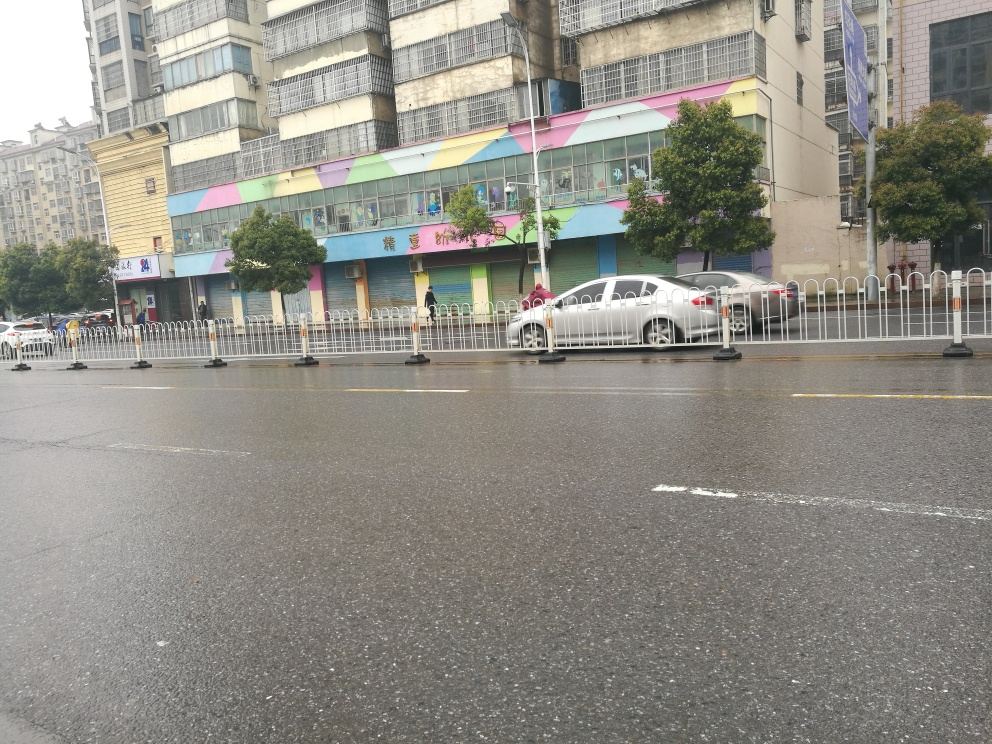Can you tell me more about the setting of this image? This image captures a street scene likely in a commercial or mixed residential area, given the storefronts with colorful facades. The barricades along the road could indicate that there is moderate to heavy traffic, and the area is pedestrian-regulated. 